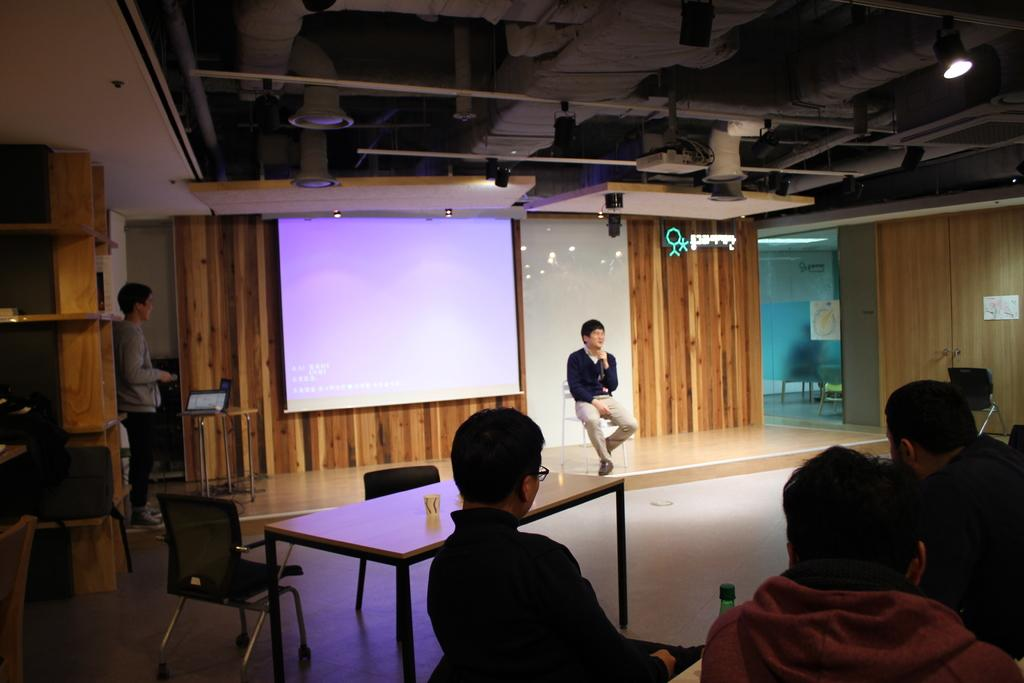How many people are in the image? There are multiple people in the image. What is the position of one of the men in the image? One man is sitting on a stool. What electronic device is present in the image? There is a laptop in the image. What is the purpose of the projector screen in the image? The projector screen is likely used for displaying information or presentations. What year is depicted on the projector screen in the image? There is no year visible on the projector screen in the image. Is there any blood or poison present in the image? No, there is no blood or poison present in the image. 